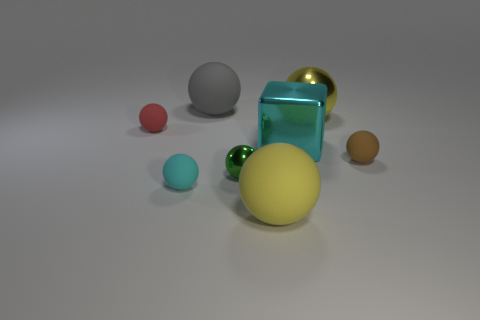There is a brown thing that is the same shape as the small cyan thing; what is its size?
Your answer should be very brief. Small. Is there anything else that is the same size as the yellow shiny ball?
Keep it short and to the point. Yes. Are there any small red things in front of the large cube?
Your answer should be very brief. No. Does the large matte object in front of the gray matte sphere have the same color as the metallic object behind the big cyan shiny object?
Your answer should be very brief. Yes. Is there a large cyan object that has the same shape as the tiny green thing?
Offer a very short reply. No. What number of other things are there of the same color as the tiny metal ball?
Offer a terse response. 0. There is a big matte sphere behind the large yellow ball that is to the left of the large yellow thing that is on the right side of the large cyan metallic object; what is its color?
Your answer should be very brief. Gray. Is the number of tiny cyan objects that are behind the green shiny ball the same as the number of green metallic cylinders?
Your answer should be very brief. Yes. There is a rubber ball in front of the cyan ball; does it have the same size as the big gray sphere?
Keep it short and to the point. Yes. What number of small things are there?
Your response must be concise. 4. 